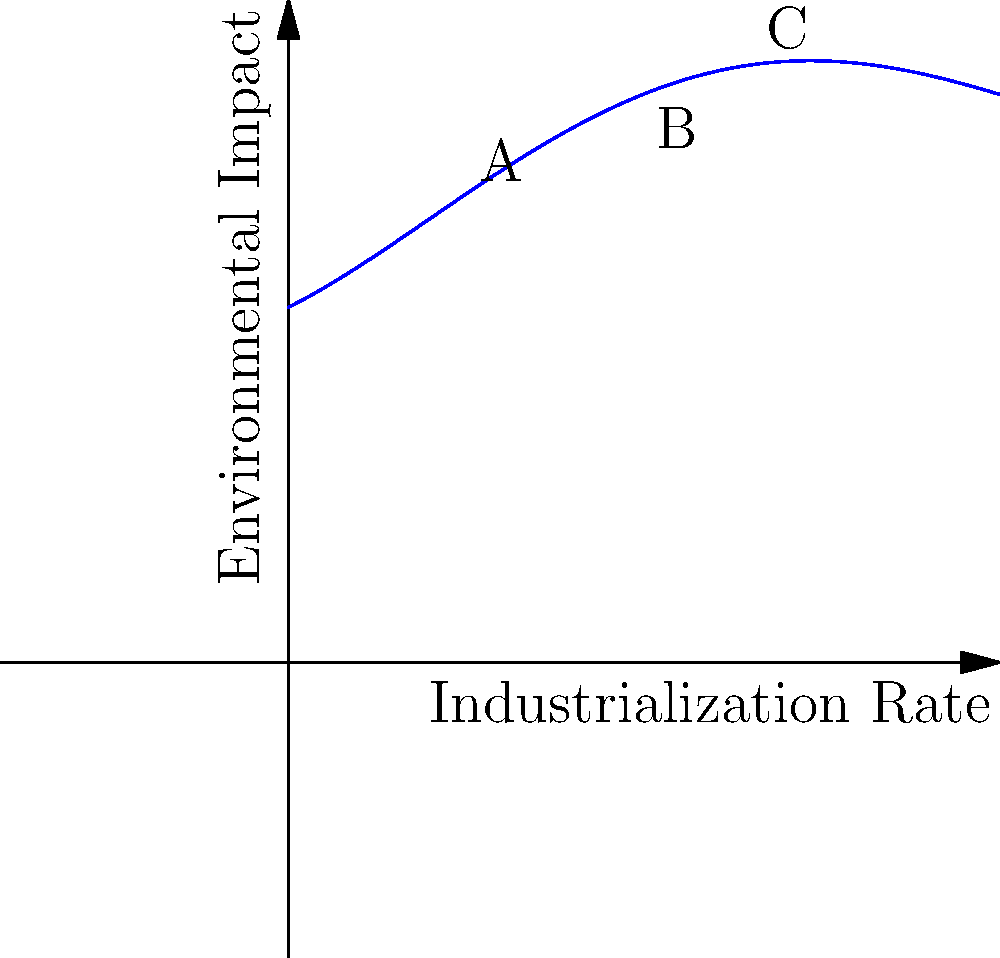The graph above represents the relationship between industrialization rates and environmental impact using a quartic polynomial. At which point (A, B, or C) does the rate of change in environmental impact with respect to industrialization rate appear to be the highest? Justify your answer using the concept of derivatives. To determine where the rate of change is highest, we need to consider the derivative of the function, which represents the slope of the tangent line at any given point.

1. The steepness of the curve indicates the rate of change.
2. The derivative of a quartic function is a cubic function.
3. Visually examining the graph:
   - At point A, the curve is rising steadily.
   - At point B, the curve appears to have the steepest slope.
   - At point C, the curve is rising more rapidly than at A, but less steeply than at B.

4. The steepest slope corresponds to the highest value of the first derivative.
5. Point B appears to have the steepest tangent line among the three points.

Therefore, the rate of change in environmental impact with respect to industrialization rate appears to be highest at point B.

This analysis demonstrates how derivatives can be used to analyze the relationship between industrialization and environmental impact, a key consideration in studying the historical development and consequences of capitalism.
Answer: Point B 